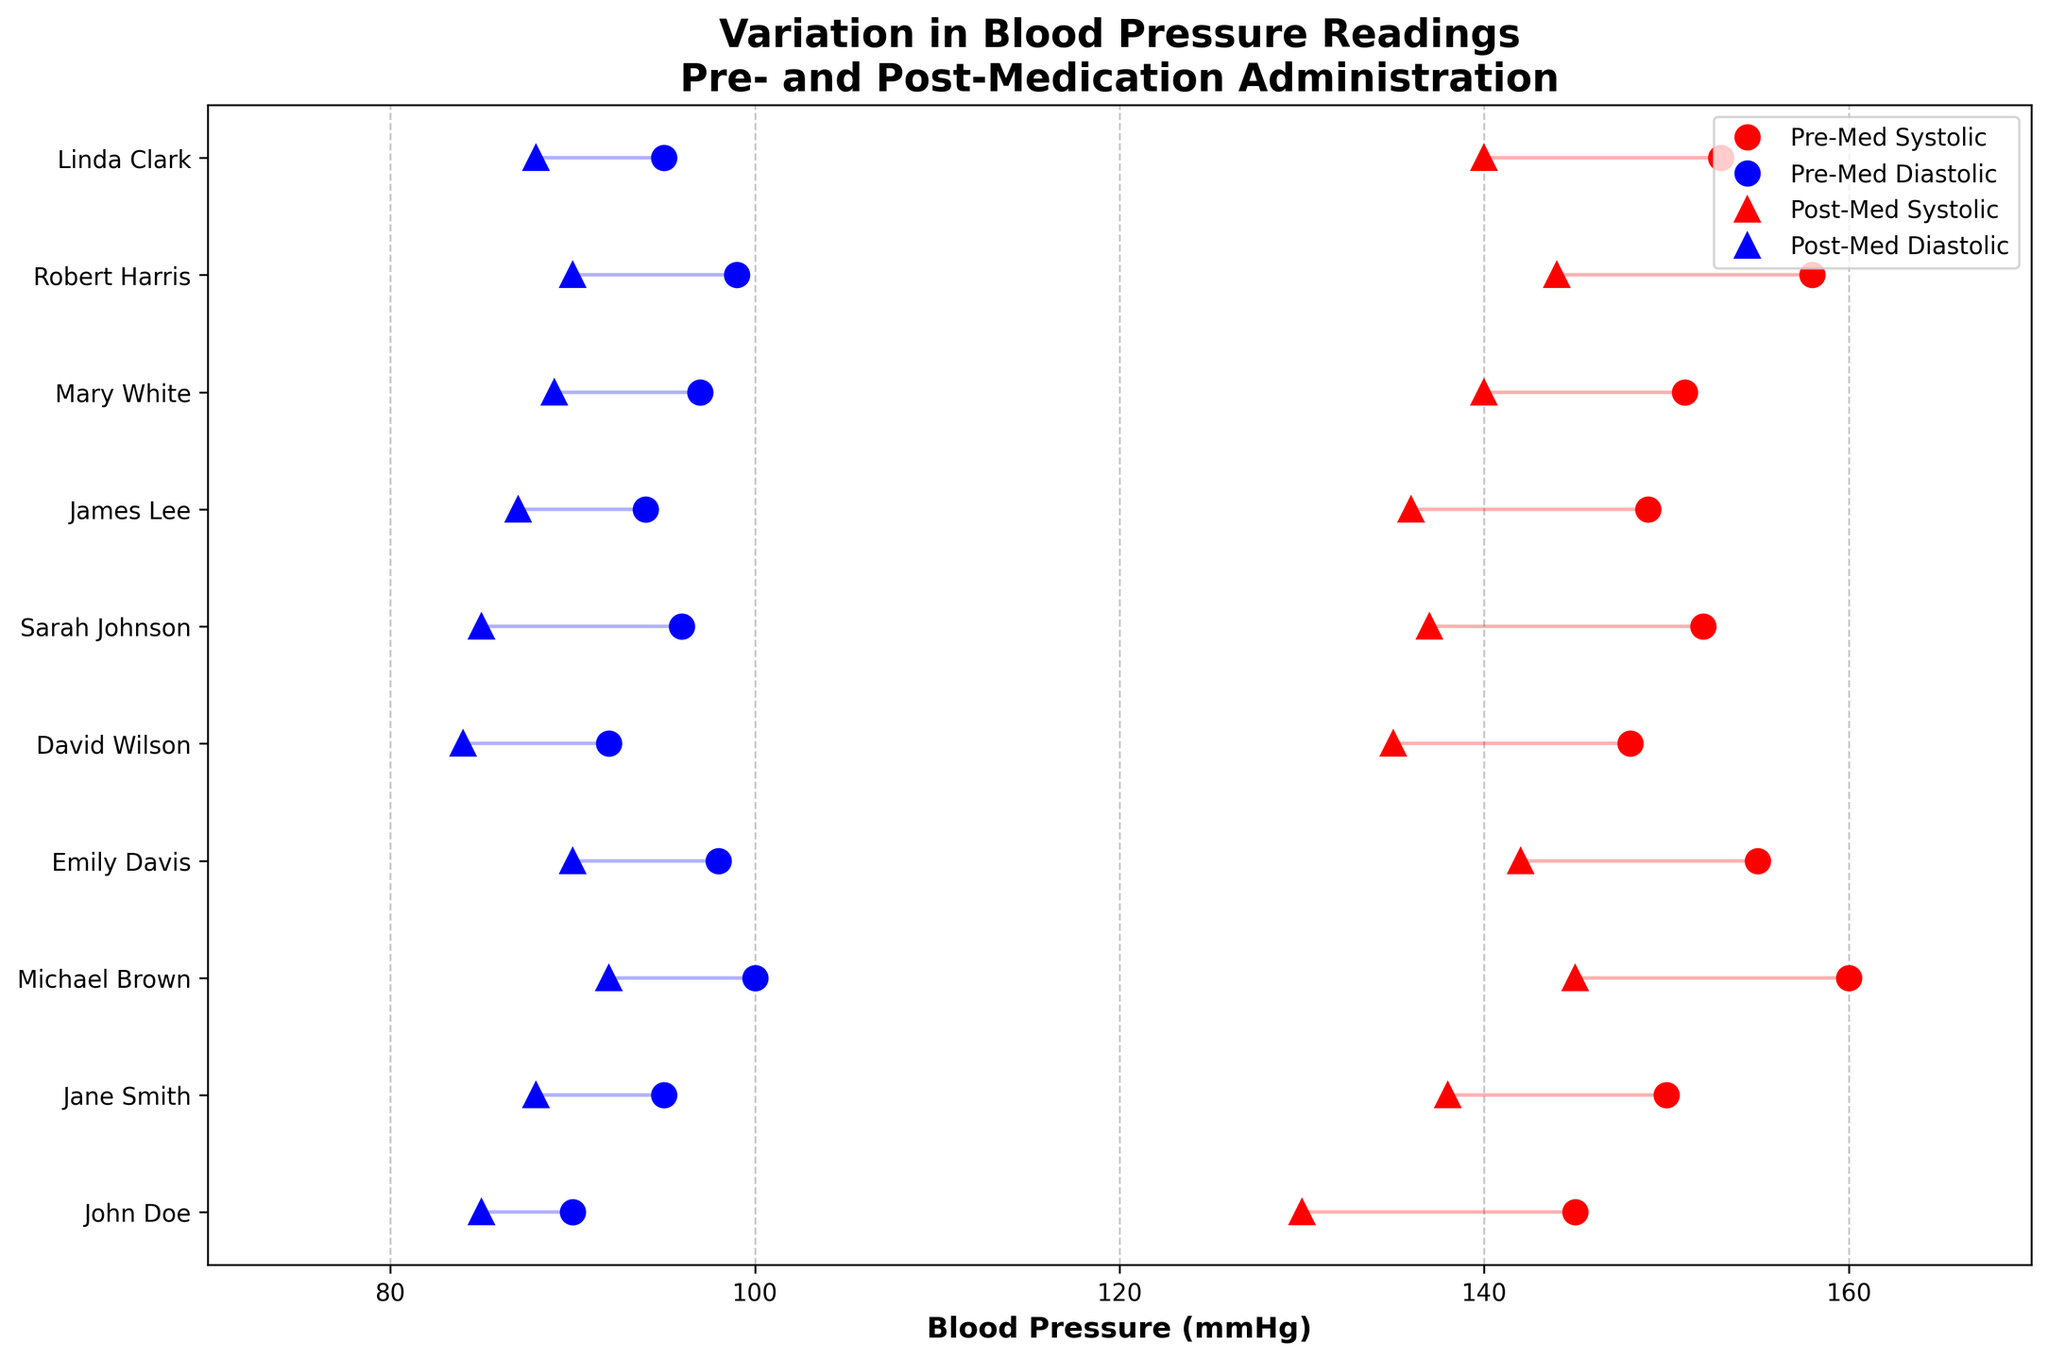What is the title of the plot? The title is typically found at the top of the plot and describes the content or purpose of the visualization. In this case, the title is "Variation in Blood Pressure Readings Pre- and Post-Medication Administration".
Answer: Variation in Blood Pressure Readings Pre- and Post-Medication Administration How many patients' data are represented in the plot? This plot has multiple markers along the y-axis, each representing a distinct patient. Counting the unique markers (dots or triangles) on the y-axis gives the number of patients. In this plot, there are dots for 10 different patients.
Answer: 10 Which patient showed the highest pre-medication systolic blood pressure? Locate the red dots representing the pre-medication systolic readings. Identify the highest red dot, which in this case corresponds to Michael Brown with 160 mmHg.
Answer: Michael Brown How does Sarah Johnson's blood pressure change after medication? To answer this, compare both systolic and diastolic readings pre- and post-medication for Sarah Johnson. Pre-medication systolic/diastolic readings are 152/96 mmHg, and post-medication readings are 137/85 mmHg. Both systolic and diastolic blood pressure decreased after medication.
Answer: Both systolic and diastolic decreased What is the average post-medication diastolic blood pressure for all patients? First, identify all the diastolic readings after medication (the blue triangles). These values are: 85, 88, 92, 90, 84, 85, 87, 89, 90, and 88. Adding these up, (85 + 88 + 92 + 90 + 84 + 85 + 87 + 89 + 90 + 88) = 878. Dividing by 10 gives the average, 87.8 mmHg.
Answer: 87.8 mmHg Did any patient show no change in their diastolic blood pressure post-medication? Compare the blue dots and blue triangles for each patient. Identify if any overlap perfectly. In this plot, all patients show a decrease in diastolic blood pressure, hence no patient has an unchanged diastolic reading.
Answer: No Which patient had the smallest reduction in systolic blood pressure post-medication? Compare the difference between the red dot and red triangle for each patient. Identify the smallest difference. James Lee had the smallest reduction, moving from 149 mmHg pre-medication to 136 mmHg post-medication, a reduction of 13 mmHg.
Answer: James Lee Are there any patients where the diastolic blood pressure decreased by at least 10 mmHg post-medication? Calculate the difference between the pre-medication (blue dot) and post-medication (blue triangle) diastolic readings for each patient. Sarah Johnson's diastolic blood pressure decreased from 96 to 85 mmHg, a change of 11 mmHg.
Answer: Sarah Johnson 